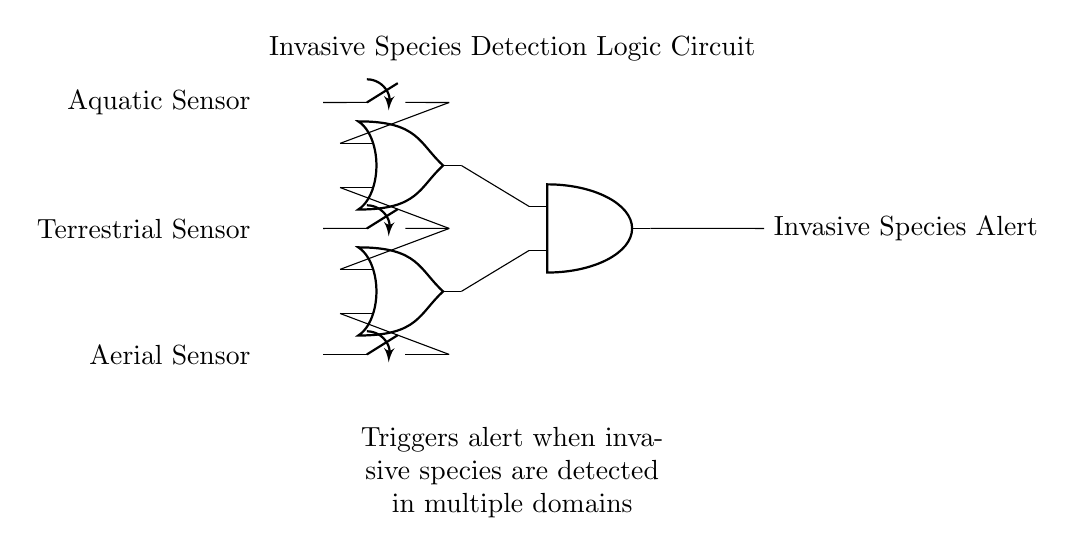What types of sensors are used in this circuit? The circuit includes three types of sensors: Aquatic, Terrestrial, and Aerial Sensors, as indicated on the left side of the diagram.
Answer: Aquatic, Terrestrial, Aerial How many inputs are feeding into the AND gate? The AND gate has two inputs, which are connected to the outputs of the two OR gates that process the sensor signals.
Answer: Two What is the function of the OR gates in this circuit? The OR gates aggregate signals from the sensors. The first OR gate responds if either the Aquatic or Terrestrial Sensor is activated, while the second OR gate responds if either the Terrestrial or Aerial Sensor is activated.
Answer: Signal aggregation What triggers the Invasive Species Alert? The Invasive Species Alert is triggered when the AND gate receives a signal from both OR gates, meaning multiple sensor types have detected an invasive species.
Answer: Multiple sensor detections Which sensors contribute to the first OR gate? The first OR gate takes inputs from the Aquatic Sensor and the Terrestrial Sensor as its two input connections.
Answer: Aquatic, Terrestrial What is the overall purpose of this logic circuit? The logic circuit is designed to monitor the detection of invasive species across different environments (aquatic, terrestrial, aerial) and consolidate that information to issue an alert if necessary.
Answer: Invasive species monitoring 